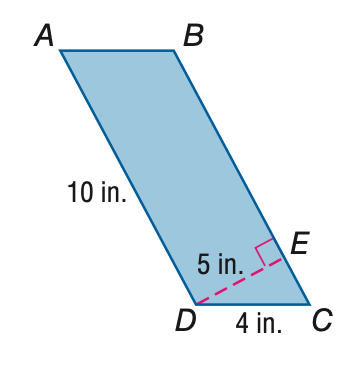Answer the mathemtical geometry problem and directly provide the correct option letter.
Question: Find the perimeter of \parallelogram A B C D.
Choices: A: 20 B: 24 C: 28 D: 32 C 